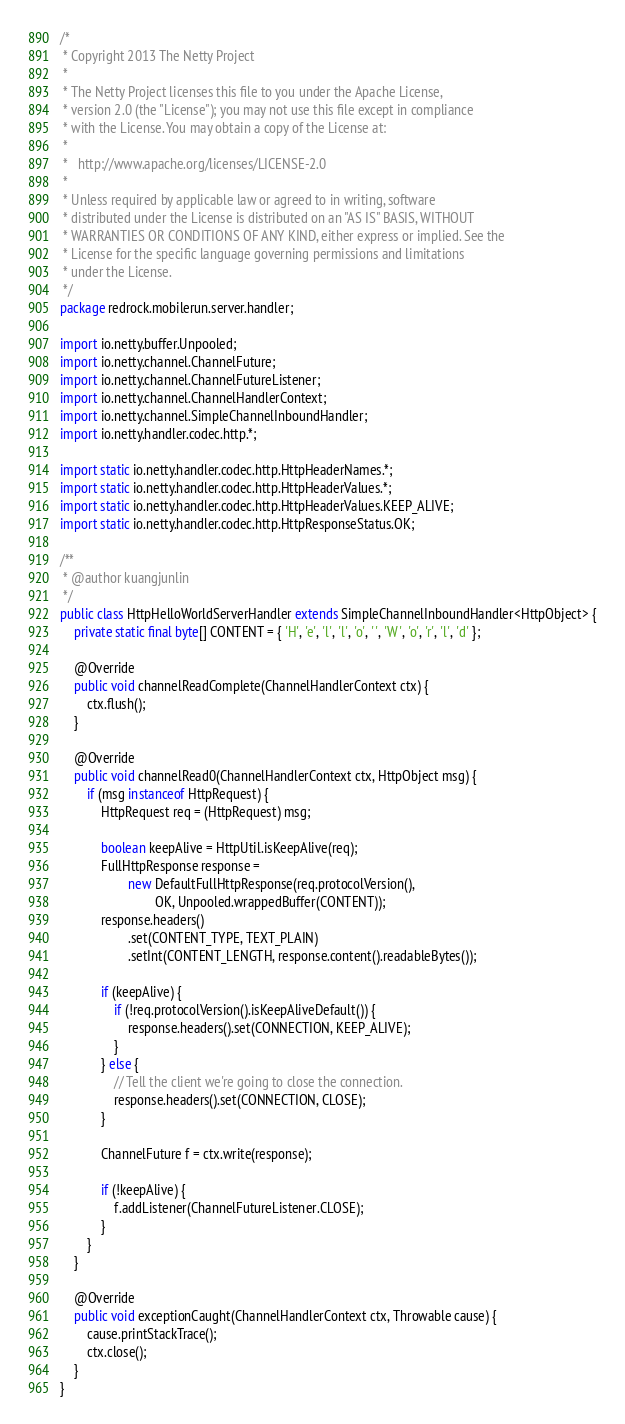<code> <loc_0><loc_0><loc_500><loc_500><_Java_>/*
 * Copyright 2013 The Netty Project
 *
 * The Netty Project licenses this file to you under the Apache License,
 * version 2.0 (the "License"); you may not use this file except in compliance
 * with the License. You may obtain a copy of the License at:
 *
 *   http://www.apache.org/licenses/LICENSE-2.0
 *
 * Unless required by applicable law or agreed to in writing, software
 * distributed under the License is distributed on an "AS IS" BASIS, WITHOUT
 * WARRANTIES OR CONDITIONS OF ANY KIND, either express or implied. See the
 * License for the specific language governing permissions and limitations
 * under the License.
 */
package redrock.mobilerun.server.handler;

import io.netty.buffer.Unpooled;
import io.netty.channel.ChannelFuture;
import io.netty.channel.ChannelFutureListener;
import io.netty.channel.ChannelHandlerContext;
import io.netty.channel.SimpleChannelInboundHandler;
import io.netty.handler.codec.http.*;

import static io.netty.handler.codec.http.HttpHeaderNames.*;
import static io.netty.handler.codec.http.HttpHeaderValues.*;
import static io.netty.handler.codec.http.HttpHeaderValues.KEEP_ALIVE;
import static io.netty.handler.codec.http.HttpResponseStatus.OK;

/**
 * @author kuangjunlin
 */
public class HttpHelloWorldServerHandler extends SimpleChannelInboundHandler<HttpObject> {
    private static final byte[] CONTENT = { 'H', 'e', 'l', 'l', 'o', ' ', 'W', 'o', 'r', 'l', 'd' };

    @Override
    public void channelReadComplete(ChannelHandlerContext ctx) {
        ctx.flush();
    }

    @Override
    public void channelRead0(ChannelHandlerContext ctx, HttpObject msg) {
        if (msg instanceof HttpRequest) {
            HttpRequest req = (HttpRequest) msg;

            boolean keepAlive = HttpUtil.isKeepAlive(req);
            FullHttpResponse response =
                    new DefaultFullHttpResponse(req.protocolVersion(),
                            OK, Unpooled.wrappedBuffer(CONTENT));
            response.headers()
                    .set(CONTENT_TYPE, TEXT_PLAIN)
                    .setInt(CONTENT_LENGTH, response.content().readableBytes());

            if (keepAlive) {
                if (!req.protocolVersion().isKeepAliveDefault()) {
                    response.headers().set(CONNECTION, KEEP_ALIVE);
                }
            } else {
                // Tell the client we're going to close the connection.
                response.headers().set(CONNECTION, CLOSE);
            }

            ChannelFuture f = ctx.write(response);

            if (!keepAlive) {
                f.addListener(ChannelFutureListener.CLOSE);
            }
        }
    }

    @Override
    public void exceptionCaught(ChannelHandlerContext ctx, Throwable cause) {
        cause.printStackTrace();
        ctx.close();
    }
}
</code> 